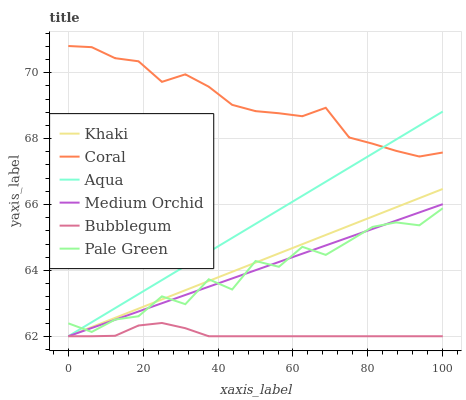Does Medium Orchid have the minimum area under the curve?
Answer yes or no. No. Does Medium Orchid have the maximum area under the curve?
Answer yes or no. No. Is Coral the smoothest?
Answer yes or no. No. Is Coral the roughest?
Answer yes or no. No. Does Coral have the lowest value?
Answer yes or no. No. Does Medium Orchid have the highest value?
Answer yes or no. No. Is Bubblegum less than Coral?
Answer yes or no. Yes. Is Coral greater than Medium Orchid?
Answer yes or no. Yes. Does Bubblegum intersect Coral?
Answer yes or no. No. 